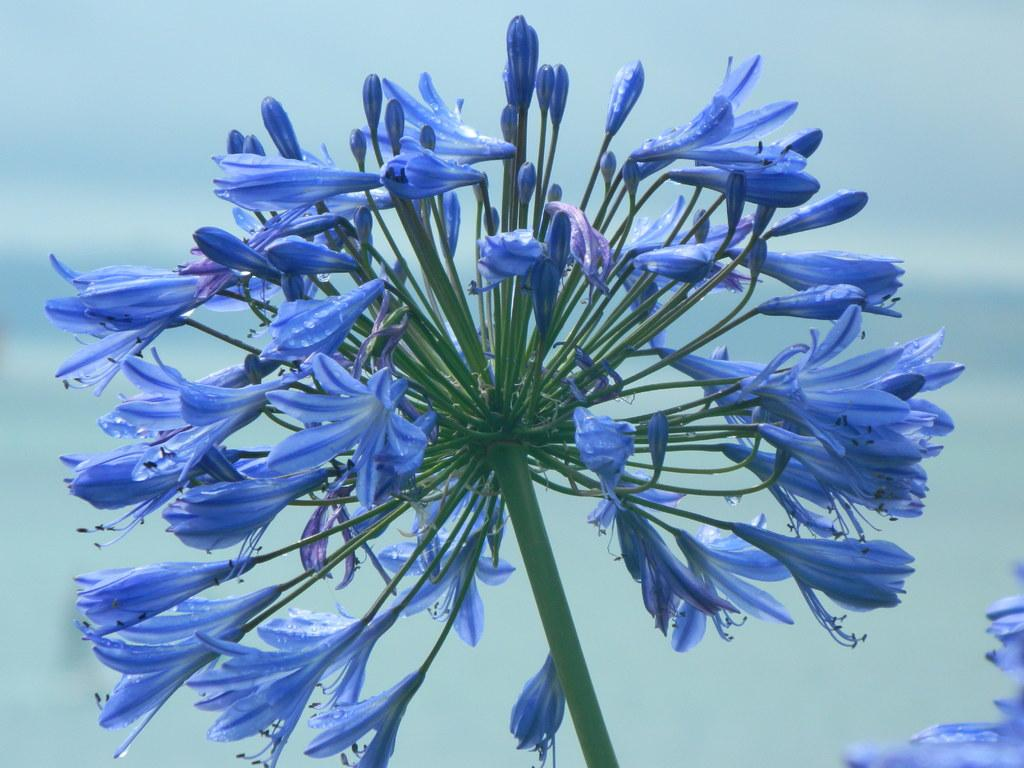What type of living organisms can be seen in the image? There are flowers in the image. Can you describe the background of the image? The background of the image is blurred. What type of flame can be seen in the image? There is no flame present in the image; it features flowers and a blurred background. What type of competition is taking place in the image? There is no competition present in the image; it features flowers and a blurred background. 